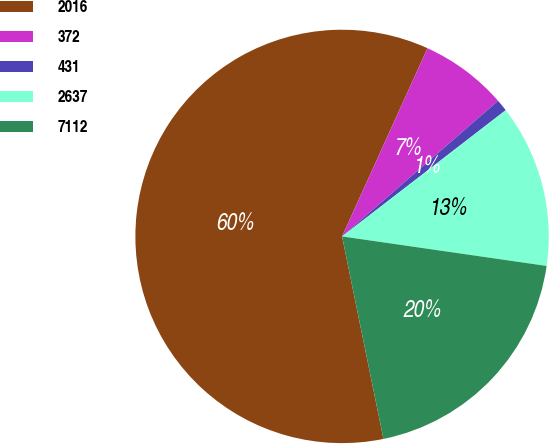Convert chart. <chart><loc_0><loc_0><loc_500><loc_500><pie_chart><fcel>2016<fcel>372<fcel>431<fcel>2637<fcel>7112<nl><fcel>59.99%<fcel>6.83%<fcel>0.93%<fcel>12.74%<fcel>19.51%<nl></chart> 